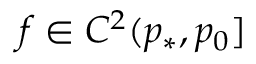<formula> <loc_0><loc_0><loc_500><loc_500>f \in C ^ { 2 } ( p _ { * } , p _ { 0 } ]</formula> 